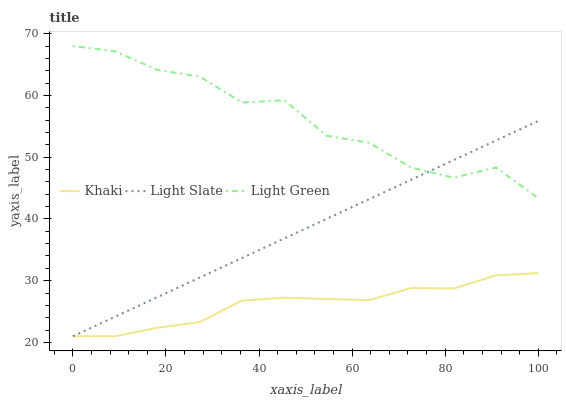Does Khaki have the minimum area under the curve?
Answer yes or no. Yes. Does Light Green have the maximum area under the curve?
Answer yes or no. Yes. Does Light Green have the minimum area under the curve?
Answer yes or no. No. Does Khaki have the maximum area under the curve?
Answer yes or no. No. Is Light Slate the smoothest?
Answer yes or no. Yes. Is Light Green the roughest?
Answer yes or no. Yes. Is Khaki the smoothest?
Answer yes or no. No. Is Khaki the roughest?
Answer yes or no. No. Does Light Slate have the lowest value?
Answer yes or no. Yes. Does Light Green have the lowest value?
Answer yes or no. No. Does Light Green have the highest value?
Answer yes or no. Yes. Does Khaki have the highest value?
Answer yes or no. No. Is Khaki less than Light Green?
Answer yes or no. Yes. Is Light Green greater than Khaki?
Answer yes or no. Yes. Does Light Slate intersect Light Green?
Answer yes or no. Yes. Is Light Slate less than Light Green?
Answer yes or no. No. Is Light Slate greater than Light Green?
Answer yes or no. No. Does Khaki intersect Light Green?
Answer yes or no. No. 